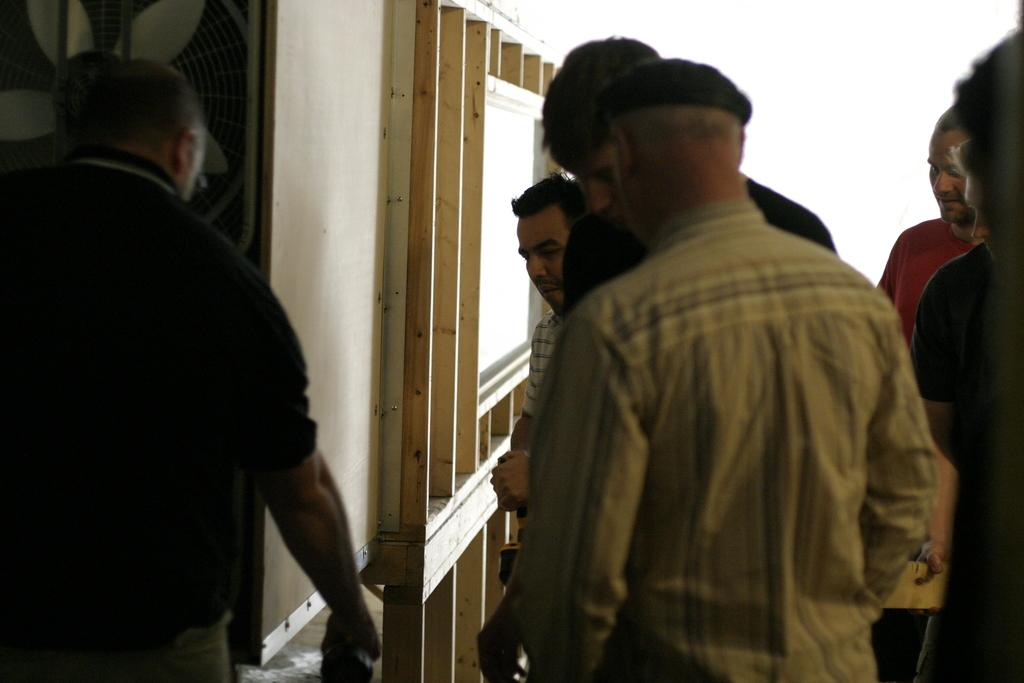How many people are present in the image? There are many people in the image. What can be seen on the wooden stand in the image? There are wooden pieces on the wooden stand in the image. Where is the fan located in the image? The fan is on the left side of the image. What is one person doing with their hand in the image? One person is holding something in their hand. What type of pest can be seen crawling on the wooden stand in the image? There are no pests visible in the image, and therefore no such activity can be observed. 